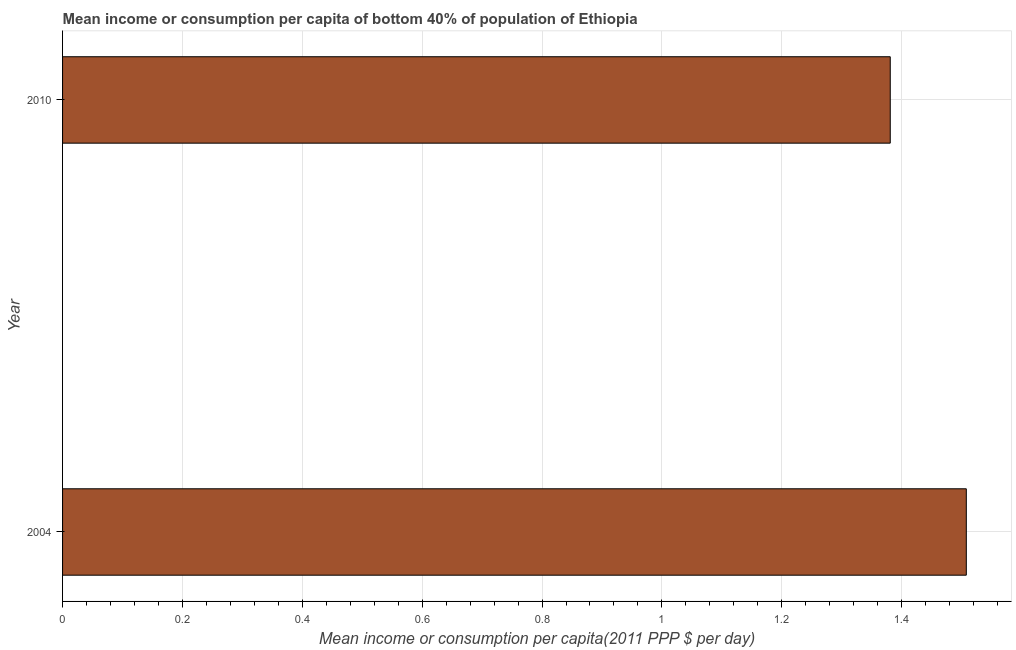Does the graph contain any zero values?
Make the answer very short. No. Does the graph contain grids?
Offer a terse response. Yes. What is the title of the graph?
Offer a very short reply. Mean income or consumption per capita of bottom 40% of population of Ethiopia. What is the label or title of the X-axis?
Your answer should be compact. Mean income or consumption per capita(2011 PPP $ per day). What is the label or title of the Y-axis?
Your answer should be compact. Year. What is the mean income or consumption in 2010?
Make the answer very short. 1.38. Across all years, what is the maximum mean income or consumption?
Your answer should be compact. 1.51. Across all years, what is the minimum mean income or consumption?
Offer a terse response. 1.38. In which year was the mean income or consumption maximum?
Give a very brief answer. 2004. In which year was the mean income or consumption minimum?
Your answer should be very brief. 2010. What is the sum of the mean income or consumption?
Ensure brevity in your answer.  2.89. What is the difference between the mean income or consumption in 2004 and 2010?
Your response must be concise. 0.13. What is the average mean income or consumption per year?
Make the answer very short. 1.44. What is the median mean income or consumption?
Provide a short and direct response. 1.44. In how many years, is the mean income or consumption greater than 0.72 $?
Provide a short and direct response. 2. Do a majority of the years between 2010 and 2004 (inclusive) have mean income or consumption greater than 0.36 $?
Provide a short and direct response. No. What is the ratio of the mean income or consumption in 2004 to that in 2010?
Give a very brief answer. 1.09. How many bars are there?
Give a very brief answer. 2. Are the values on the major ticks of X-axis written in scientific E-notation?
Keep it short and to the point. No. What is the Mean income or consumption per capita(2011 PPP $ per day) in 2004?
Provide a succinct answer. 1.51. What is the Mean income or consumption per capita(2011 PPP $ per day) of 2010?
Provide a succinct answer. 1.38. What is the difference between the Mean income or consumption per capita(2011 PPP $ per day) in 2004 and 2010?
Provide a succinct answer. 0.13. What is the ratio of the Mean income or consumption per capita(2011 PPP $ per day) in 2004 to that in 2010?
Provide a short and direct response. 1.09. 